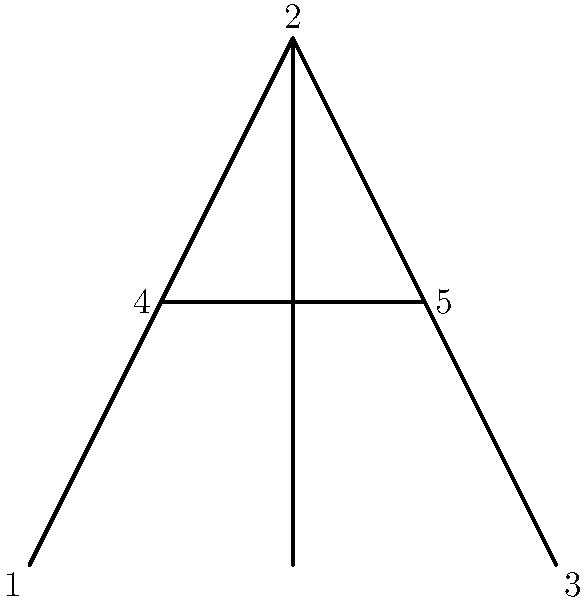In the Chinese character "大" (dà, meaning "big"), shown above with numbered strokes, what is the order of symmetry for the group of rotations that preserve the character's structure? Assume the character is centered at the intersection of strokes 3 and 4. To determine the order of symmetry for the group of rotations, we need to follow these steps:

1. Identify the center of rotation: The intersection of strokes 3 and 4.

2. Analyze possible rotations:
   a) 0° rotation (identity): Always preserves the structure.
   b) 180° rotation: The character remains unchanged.
   c) 90° or 270° rotations: These do not preserve the structure.

3. Count the number of distinct rotations that preserve the structure:
   - 0° rotation
   - 180° rotation

4. The order of symmetry is the number of these distinct rotations.

In group theory, this forms a cyclic group $C_2$, which has order 2. The group elements are:
$$ \{e, r\} $$
where $e$ is the identity (0° rotation) and $r$ is the 180° rotation.

Therefore, the order of symmetry for the group of rotations that preserve the character's structure is 2.
Answer: 2 